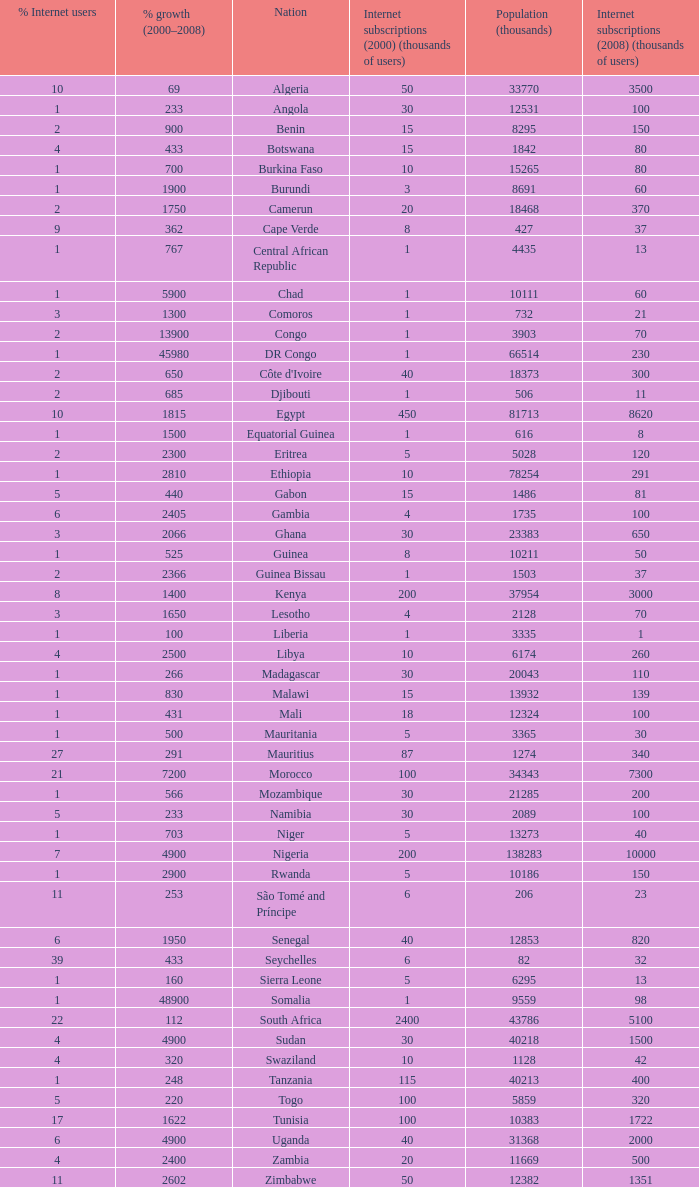What is the percentage of growth in 2000-2008 in ethiopia? 2810.0. I'm looking to parse the entire table for insights. Could you assist me with that? {'header': ['% Internet users', '% growth (2000–2008)', 'Nation', 'Internet subscriptions (2000) (thousands of users)', 'Population (thousands)', 'Internet subscriptions (2008) (thousands of users)'], 'rows': [['10', '69', 'Algeria', '50', '33770', '3500'], ['1', '233', 'Angola', '30', '12531', '100'], ['2', '900', 'Benin', '15', '8295', '150'], ['4', '433', 'Botswana', '15', '1842', '80'], ['1', '700', 'Burkina Faso', '10', '15265', '80'], ['1', '1900', 'Burundi', '3', '8691', '60'], ['2', '1750', 'Camerun', '20', '18468', '370'], ['9', '362', 'Cape Verde', '8', '427', '37'], ['1', '767', 'Central African Republic', '1', '4435', '13'], ['1', '5900', 'Chad', '1', '10111', '60'], ['3', '1300', 'Comoros', '1', '732', '21'], ['2', '13900', 'Congo', '1', '3903', '70'], ['1', '45980', 'DR Congo', '1', '66514', '230'], ['2', '650', "Côte d'Ivoire", '40', '18373', '300'], ['2', '685', 'Djibouti', '1', '506', '11'], ['10', '1815', 'Egypt', '450', '81713', '8620'], ['1', '1500', 'Equatorial Guinea', '1', '616', '8'], ['2', '2300', 'Eritrea', '5', '5028', '120'], ['1', '2810', 'Ethiopia', '10', '78254', '291'], ['5', '440', 'Gabon', '15', '1486', '81'], ['6', '2405', 'Gambia', '4', '1735', '100'], ['3', '2066', 'Ghana', '30', '23383', '650'], ['1', '525', 'Guinea', '8', '10211', '50'], ['2', '2366', 'Guinea Bissau', '1', '1503', '37'], ['8', '1400', 'Kenya', '200', '37954', '3000'], ['3', '1650', 'Lesotho', '4', '2128', '70'], ['1', '100', 'Liberia', '1', '3335', '1'], ['4', '2500', 'Libya', '10', '6174', '260'], ['1', '266', 'Madagascar', '30', '20043', '110'], ['1', '830', 'Malawi', '15', '13932', '139'], ['1', '431', 'Mali', '18', '12324', '100'], ['1', '500', 'Mauritania', '5', '3365', '30'], ['27', '291', 'Mauritius', '87', '1274', '340'], ['21', '7200', 'Morocco', '100', '34343', '7300'], ['1', '566', 'Mozambique', '30', '21285', '200'], ['5', '233', 'Namibia', '30', '2089', '100'], ['1', '703', 'Niger', '5', '13273', '40'], ['7', '4900', 'Nigeria', '200', '138283', '10000'], ['1', '2900', 'Rwanda', '5', '10186', '150'], ['11', '253', 'São Tomé and Príncipe', '6', '206', '23'], ['6', '1950', 'Senegal', '40', '12853', '820'], ['39', '433', 'Seychelles', '6', '82', '32'], ['1', '160', 'Sierra Leone', '5', '6295', '13'], ['1', '48900', 'Somalia', '1', '9559', '98'], ['22', '112', 'South Africa', '2400', '43786', '5100'], ['4', '4900', 'Sudan', '30', '40218', '1500'], ['4', '320', 'Swaziland', '10', '1128', '42'], ['1', '248', 'Tanzania', '115', '40213', '400'], ['5', '220', 'Togo', '100', '5859', '320'], ['17', '1622', 'Tunisia', '100', '10383', '1722'], ['6', '4900', 'Uganda', '40', '31368', '2000'], ['4', '2400', 'Zambia', '20', '11669', '500'], ['11', '2602', 'Zimbabwe', '50', '12382', '1351']]} 